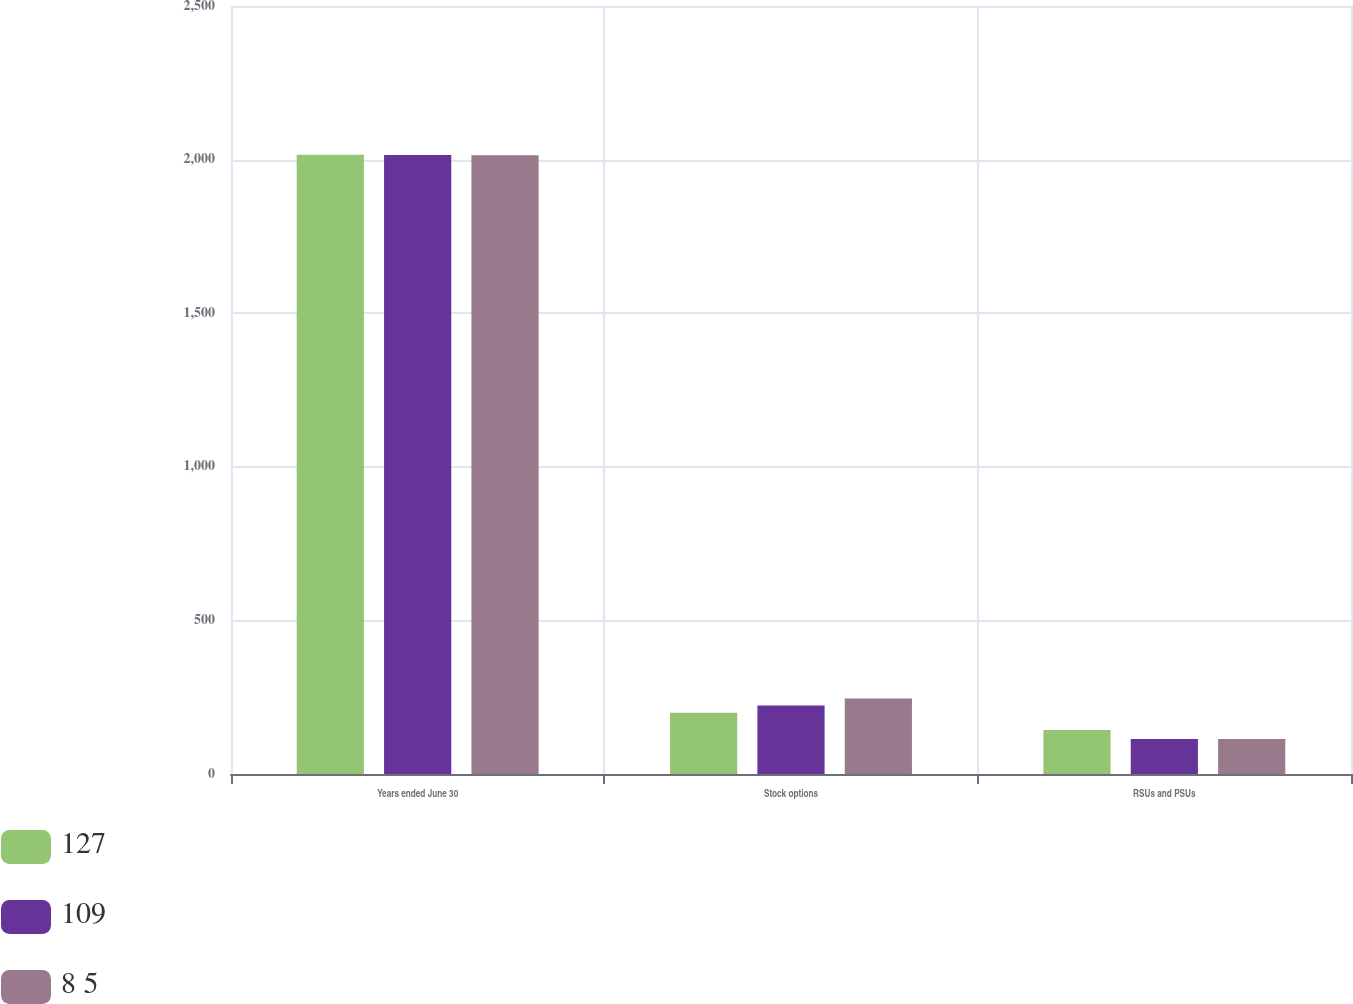<chart> <loc_0><loc_0><loc_500><loc_500><stacked_bar_chart><ecel><fcel>Years ended June 30<fcel>Stock options<fcel>RSUs and PSUs<nl><fcel>127<fcel>2016<fcel>199<fcel>143<nl><fcel>109<fcel>2015<fcel>223<fcel>114<nl><fcel>8 5<fcel>2014<fcel>246<fcel>114<nl></chart> 